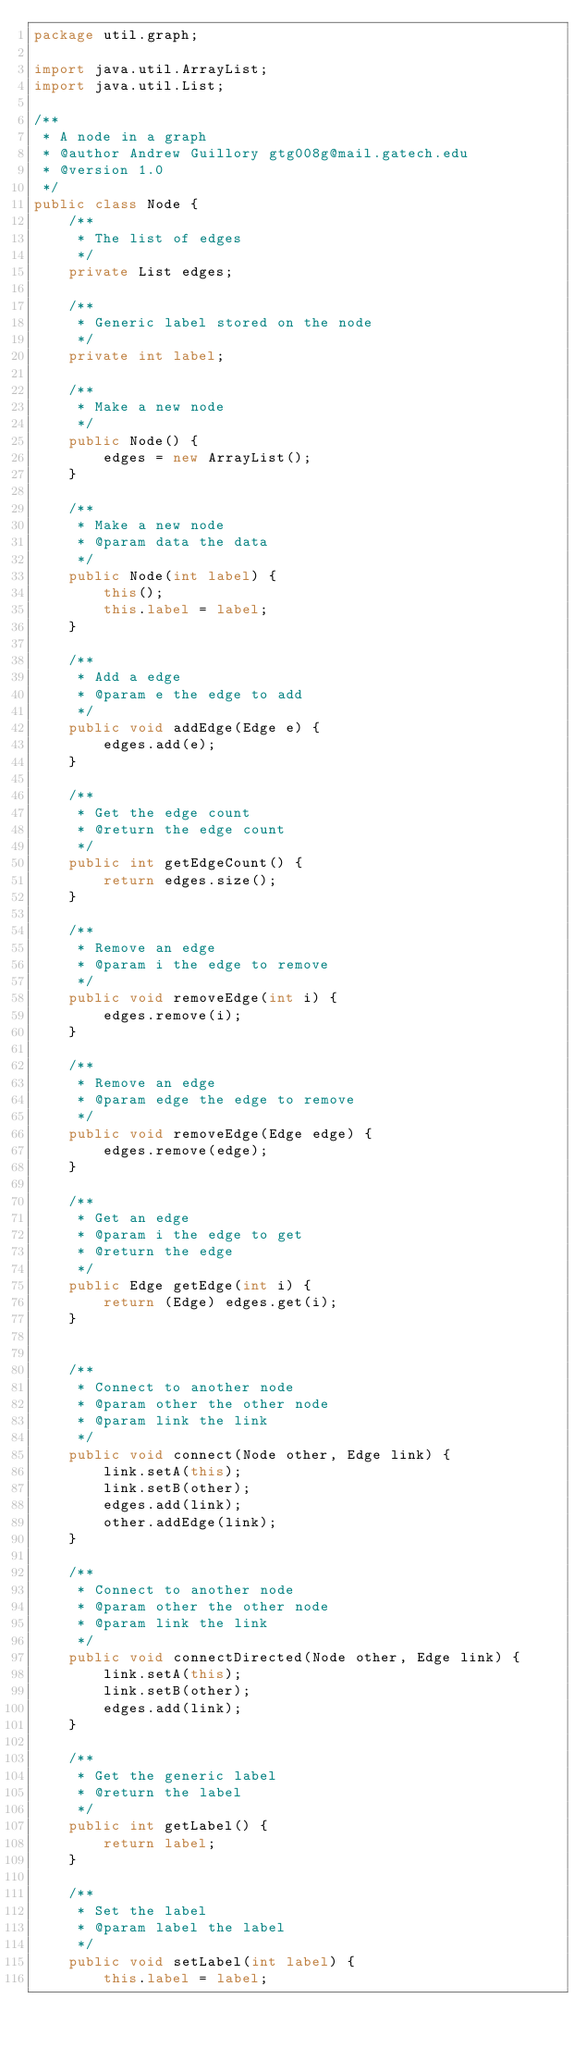<code> <loc_0><loc_0><loc_500><loc_500><_Java_>package util.graph;

import java.util.ArrayList;
import java.util.List;

/**
 * A node in a graph
 * @author Andrew Guillory gtg008g@mail.gatech.edu
 * @version 1.0
 */
public class Node {
    /**
     * The list of edges
     */
    private List edges;
    
    /**
     * Generic label stored on the node
     */
    private int label;
    
    /**
     * Make a new node
     */
    public Node() {
        edges = new ArrayList();
    }
    
    /**
     * Make a new node
     * @param data the data
     */
    public Node(int label) {
        this();
        this.label = label;
    }
    
    /**
     * Add a edge
     * @param e the edge to add
     */
    public void addEdge(Edge e) {
        edges.add(e);
    }
    
    /**
     * Get the edge count
     * @return the edge count
     */
    public int getEdgeCount() {
        return edges.size();
    }
    
    /**
     * Remove an edge
     * @param i the edge to remove
     */
    public void removeEdge(int i) {
        edges.remove(i);
    }
    
    /**
     * Remove an edge
     * @param edge the edge to remove
     */
    public void removeEdge(Edge edge) {
        edges.remove(edge);
    }
    
    /**
     * Get an edge
     * @param i the edge to get
     * @return the edge
     */
    public Edge getEdge(int i) {
        return (Edge) edges.get(i);
    }
    
    
    /**
     * Connect to another node
     * @param other the other node
     * @param link the link
     */
    public void connect(Node other, Edge link) {
        link.setA(this);
        link.setB(other);
        edges.add(link);
        other.addEdge(link);
    }
    
    /**
     * Connect to another node
     * @param other the other node
     * @param link the link
     */
    public void connectDirected(Node other, Edge link) {
        link.setA(this);
        link.setB(other);
        edges.add(link);
    }

    /**
     * Get the generic label
     * @return the label
     */
    public int getLabel() {
        return label;
    }

    /**
     * Set the label
     * @param label the label
     */
    public void setLabel(int label) {
        this.label = label;</code> 